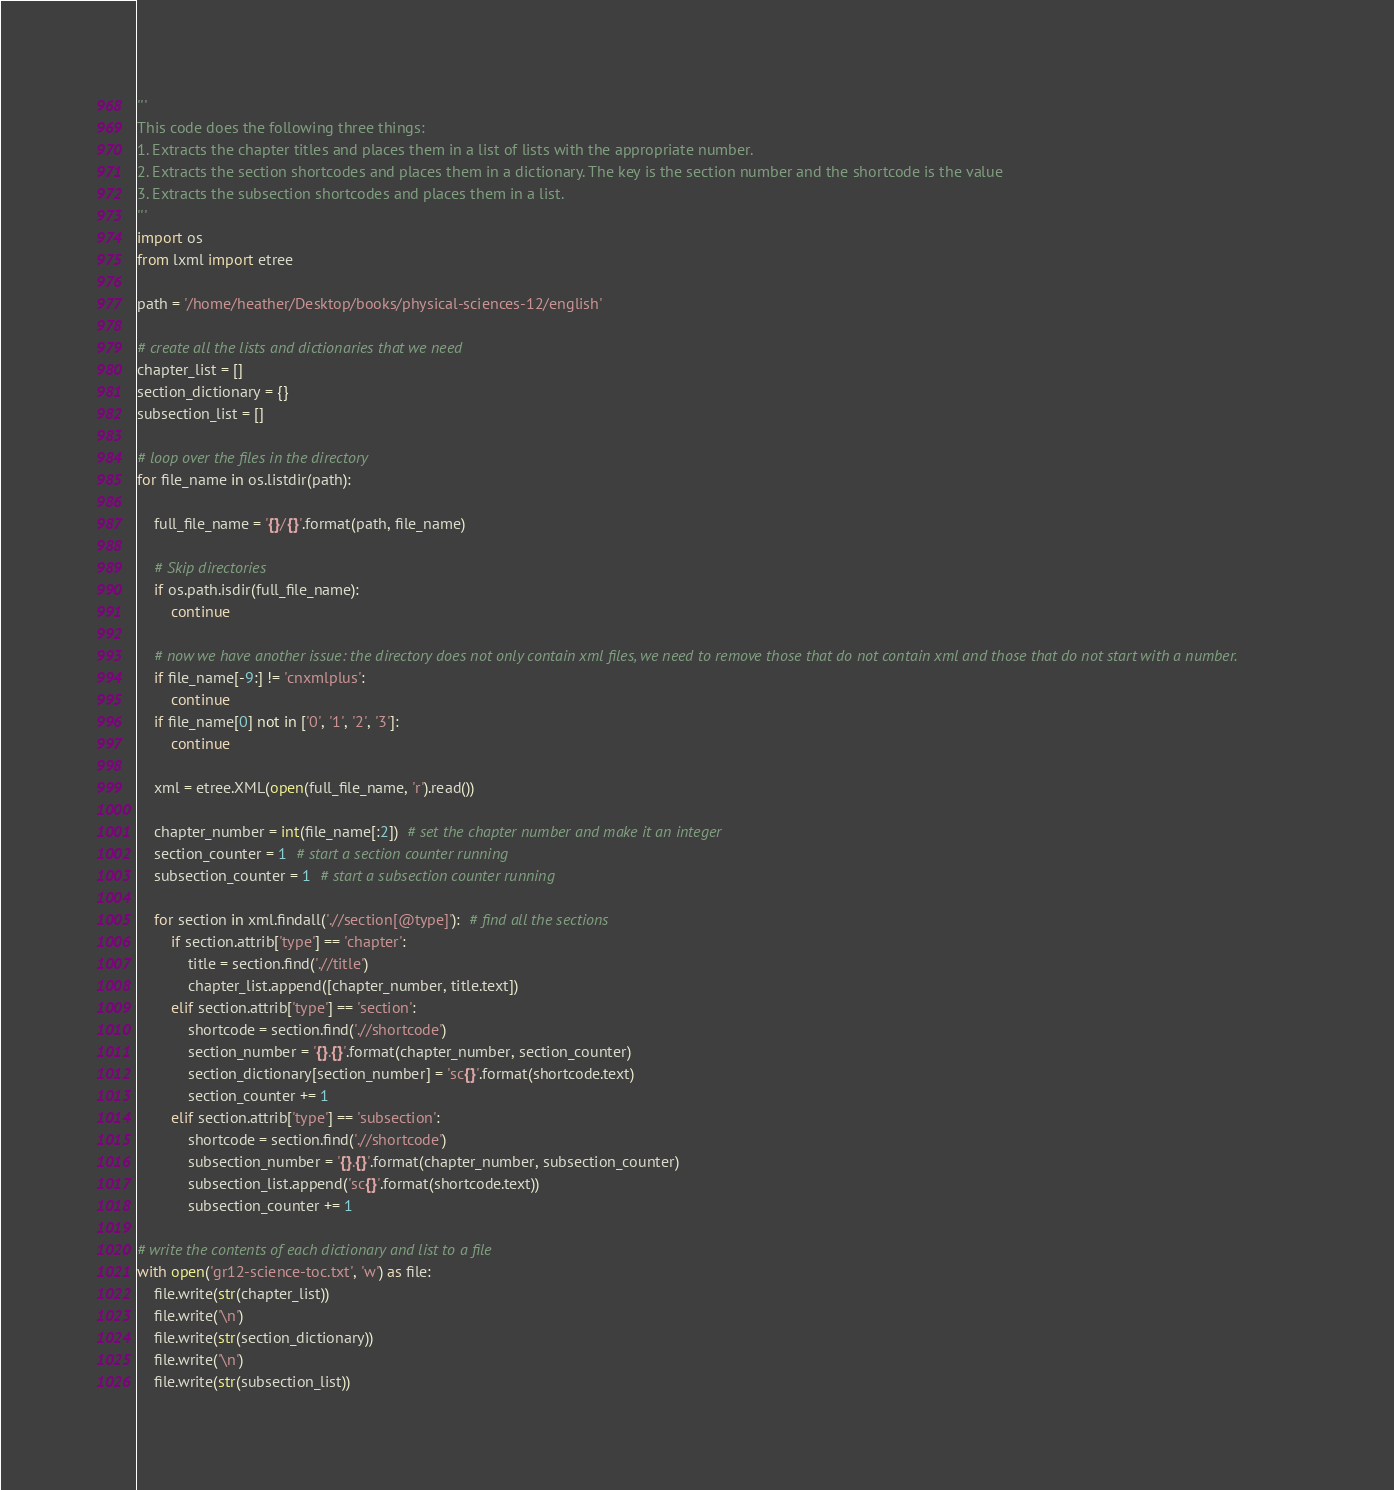Convert code to text. <code><loc_0><loc_0><loc_500><loc_500><_Python_>'''
This code does the following three things:
1. Extracts the chapter titles and places them in a list of lists with the appropriate number.
2. Extracts the section shortcodes and places them in a dictionary. The key is the section number and the shortcode is the value
3. Extracts the subsection shortcodes and places them in a list.
'''
import os
from lxml import etree

path = '/home/heather/Desktop/books/physical-sciences-12/english'

# create all the lists and dictionaries that we need
chapter_list = []
section_dictionary = {}
subsection_list = []

# loop over the files in the directory
for file_name in os.listdir(path):

    full_file_name = '{}/{}'.format(path, file_name)
    
    # Skip directories
    if os.path.isdir(full_file_name):
        continue

    # now we have another issue: the directory does not only contain xml files, we need to remove those that do not contain xml and those that do not start with a number.
    if file_name[-9:] != 'cnxmlplus':
        continue
    if file_name[0] not in ['0', '1', '2', '3']:
        continue
    
    xml = etree.XML(open(full_file_name, 'r').read())

    chapter_number = int(file_name[:2])  # set the chapter number and make it an integer
    section_counter = 1  # start a section counter running
    subsection_counter = 1  # start a subsection counter running
    
    for section in xml.findall('.//section[@type]'):  # find all the sections
        if section.attrib['type'] == 'chapter':
            title = section.find('.//title')
            chapter_list.append([chapter_number, title.text])
        elif section.attrib['type'] == 'section':
            shortcode = section.find('.//shortcode')
            section_number = '{}.{}'.format(chapter_number, section_counter)
            section_dictionary[section_number] = 'sc{}'.format(shortcode.text)
            section_counter += 1
        elif section.attrib['type'] == 'subsection':
            shortcode = section.find('.//shortcode')
            subsection_number = '{}.{}'.format(chapter_number, subsection_counter)
            subsection_list.append('sc{}'.format(shortcode.text))
            subsection_counter += 1

# write the contents of each dictionary and list to a file
with open('gr12-science-toc.txt', 'w') as file:
    file.write(str(chapter_list))
    file.write('\n')
    file.write(str(section_dictionary))
    file.write('\n')
    file.write(str(subsection_list))
</code> 